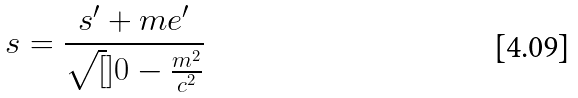<formula> <loc_0><loc_0><loc_500><loc_500>s = \frac { s ^ { \prime } + m e ^ { \prime } } { \sqrt { [ } ] { 0 - \frac { m ^ { 2 } } { c ^ { 2 } } } }</formula> 